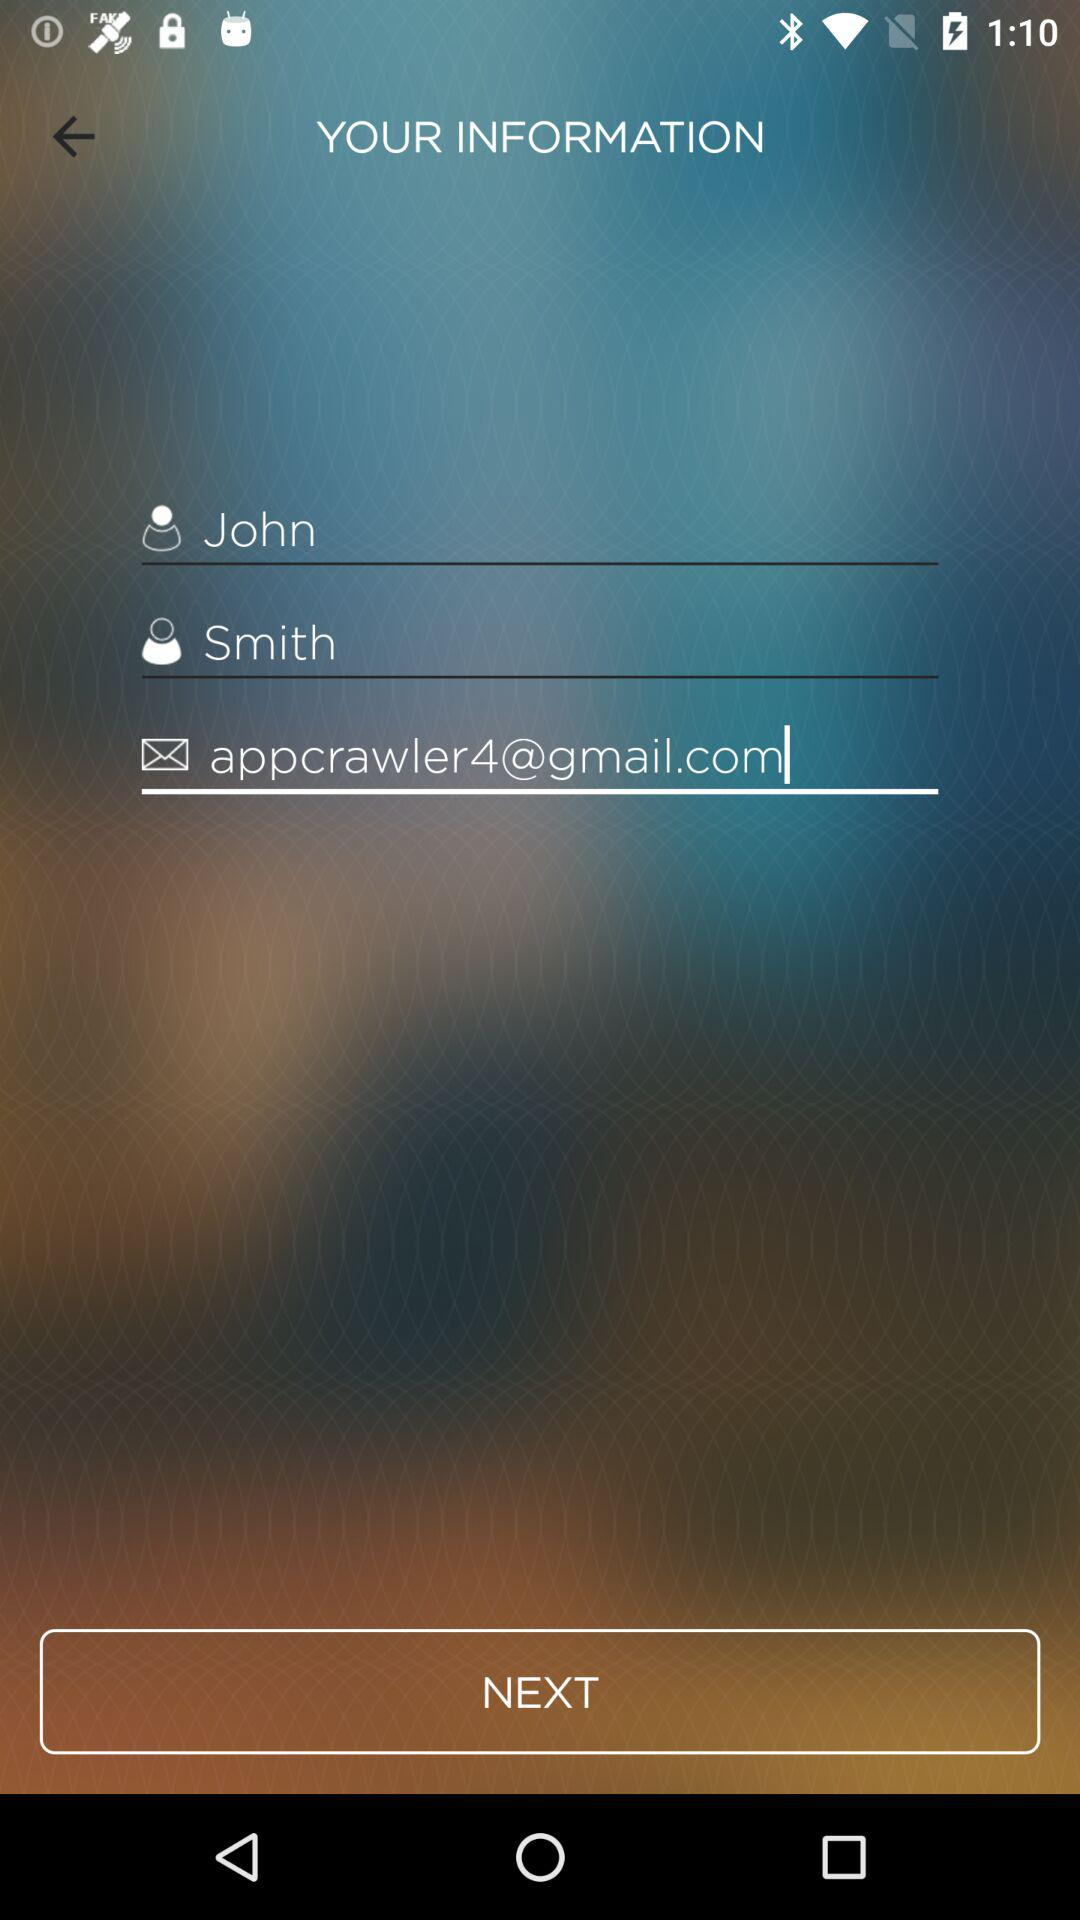What is the first name? The first name is John. 